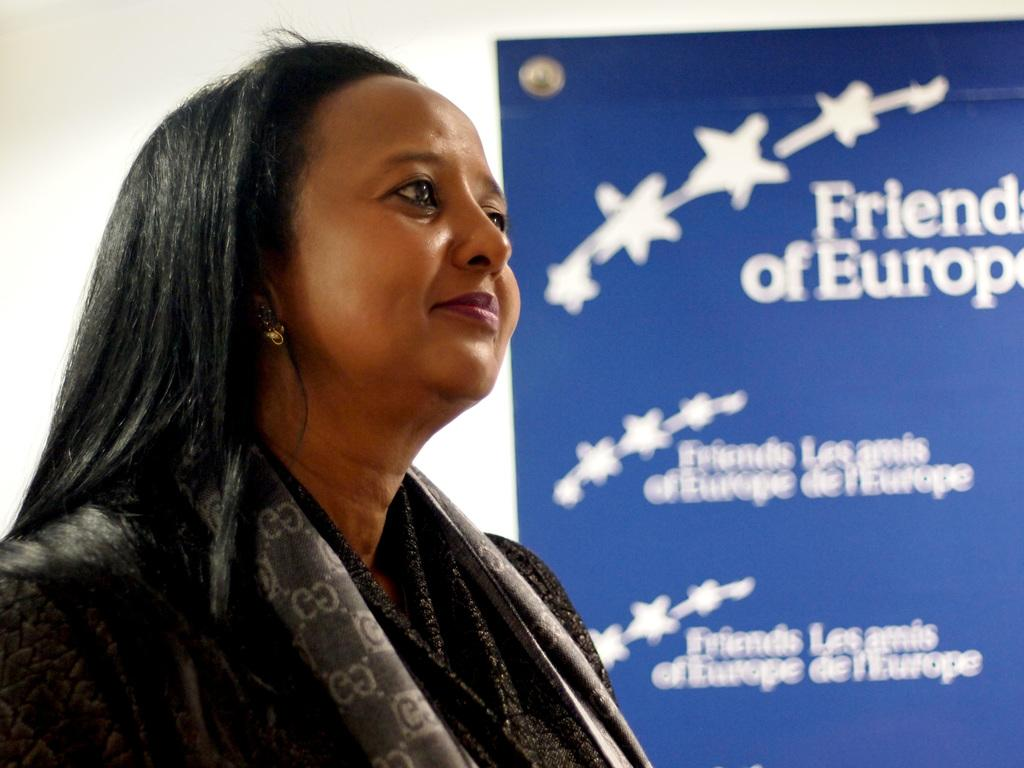Who is present in the image? There is a woman in the image. What is the woman wearing? The woman is wearing a black dress. What is the woman doing in the image? The woman is standing. What can be seen in the background of the image? There is a wall in the background of the image. What is attached to the wall? A board is fixed on the wall. What color is the board? The board is blue in color. Can you see a cushion on the floor in the image? There is no cushion visible on the floor in the image. 